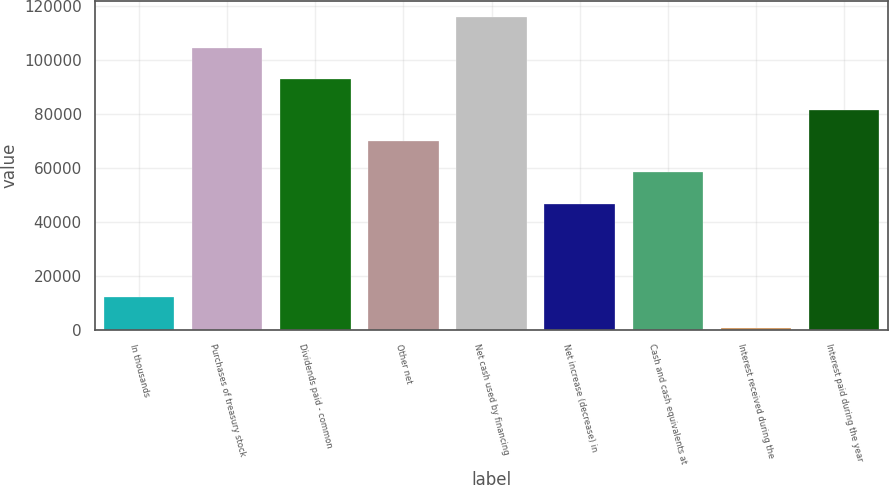Convert chart. <chart><loc_0><loc_0><loc_500><loc_500><bar_chart><fcel>In thousands<fcel>Purchases of treasury stock<fcel>Dividends paid - common<fcel>Other net<fcel>Net cash used by financing<fcel>Net increase (decrease) in<fcel>Cash and cash equivalents at<fcel>Interest received during the<fcel>Interest paid during the year<nl><fcel>12048.8<fcel>104631<fcel>93058.4<fcel>69912.8<fcel>116204<fcel>46767.2<fcel>58340<fcel>476<fcel>81485.6<nl></chart> 